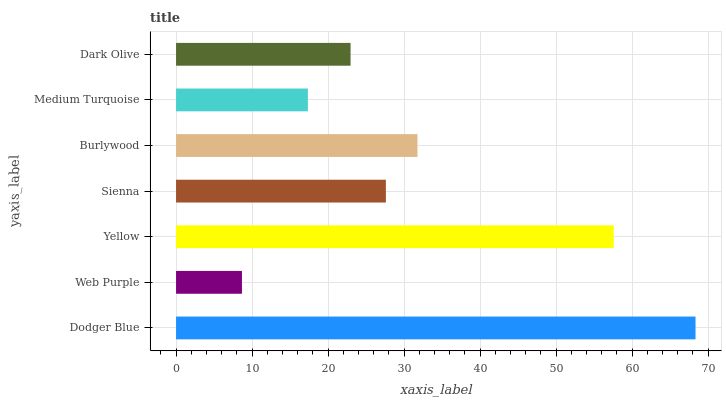Is Web Purple the minimum?
Answer yes or no. Yes. Is Dodger Blue the maximum?
Answer yes or no. Yes. Is Yellow the minimum?
Answer yes or no. No. Is Yellow the maximum?
Answer yes or no. No. Is Yellow greater than Web Purple?
Answer yes or no. Yes. Is Web Purple less than Yellow?
Answer yes or no. Yes. Is Web Purple greater than Yellow?
Answer yes or no. No. Is Yellow less than Web Purple?
Answer yes or no. No. Is Sienna the high median?
Answer yes or no. Yes. Is Sienna the low median?
Answer yes or no. Yes. Is Burlywood the high median?
Answer yes or no. No. Is Web Purple the low median?
Answer yes or no. No. 